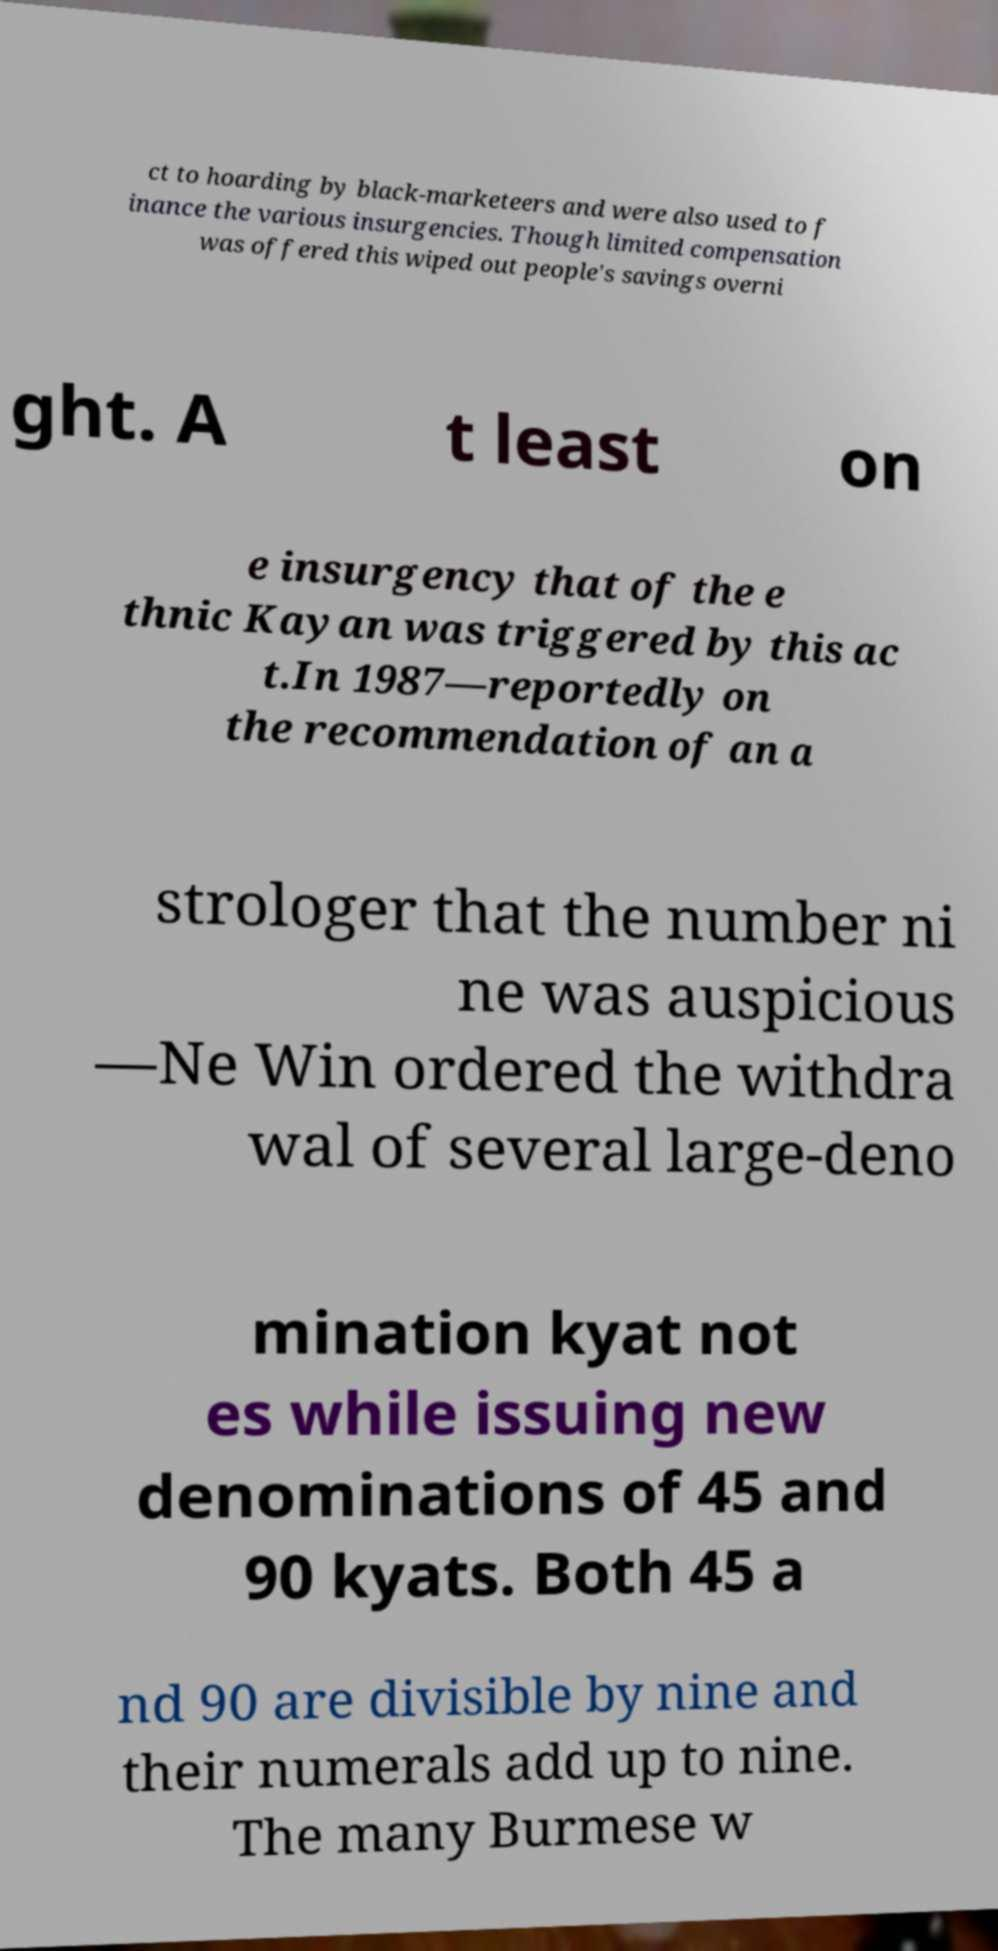I need the written content from this picture converted into text. Can you do that? ct to hoarding by black-marketeers and were also used to f inance the various insurgencies. Though limited compensation was offered this wiped out people's savings overni ght. A t least on e insurgency that of the e thnic Kayan was triggered by this ac t.In 1987—reportedly on the recommendation of an a strologer that the number ni ne was auspicious —Ne Win ordered the withdra wal of several large-deno mination kyat not es while issuing new denominations of 45 and 90 kyats. Both 45 a nd 90 are divisible by nine and their numerals add up to nine. The many Burmese w 